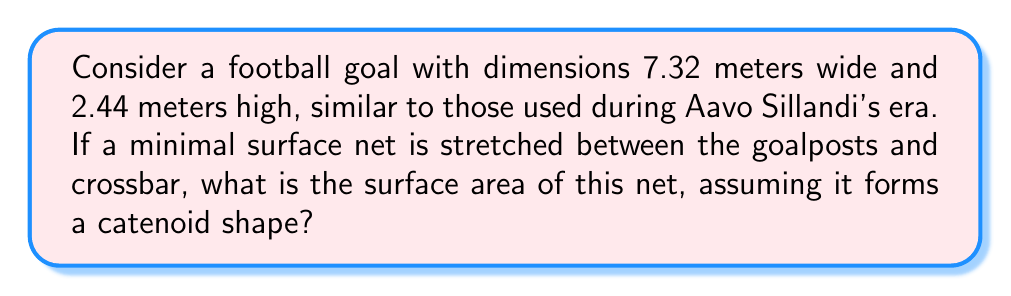Provide a solution to this math problem. Let's approach this step-by-step:

1) A catenoid is a minimal surface formed by rotating a catenary curve around an axis. In this case, we can consider the vertical axis as our axis of rotation.

2) The catenary curve is described by the equation:

   $$y = a \cosh(\frac{x}{a})$$

   where $a$ is a constant that determines the shape of the curve.

3) To find $a$, we need to use the boundary conditions. The width of the goal is 7.32 m, so $x$ ranges from -3.66 to 3.66. The height is 2.44 m. This gives us:

   $$2.44 = a \cosh(\frac{3.66}{a})$$

4) This equation can be solved numerically. Using a numerical method (e.g., Newton-Raphson), we find:

   $$a \approx 3.7858$$

5) Now, the surface area of a catenoid is given by the formula:

   $$A = 2\pi a^2 \left[\sinh(\frac{b}{a}) \cosh(\frac{b}{a}) + \frac{b}{a}\right]$$

   where $b$ is half the width of the goal, so $b = 3.66$.

6) Substituting our values:

   $$A = 2\pi (3.7858)^2 \left[\sinh(\frac{3.66}{3.7858}) \cosh(\frac{3.66}{3.7858}) + \frac{3.66}{3.7858}\right]$$

7) Calculating this:

   $$A \approx 18.9147 \text{ m}^2$$

[asy]
import graph;
size(200,100);
real f(real x) {return 3.7858*cosh(x/3.7858);}
draw(graph(f,-3.66,3.66));
draw((0,0)--(0,2.44));
draw((-3.66,0)--(3.66,0));
draw((-3.66,2.44)--(3.66,2.44));
label("7.32 m",(0,-0.2));
label("2.44 m",(3.9,1.22));
[/asy]
Answer: 18.9147 m² 